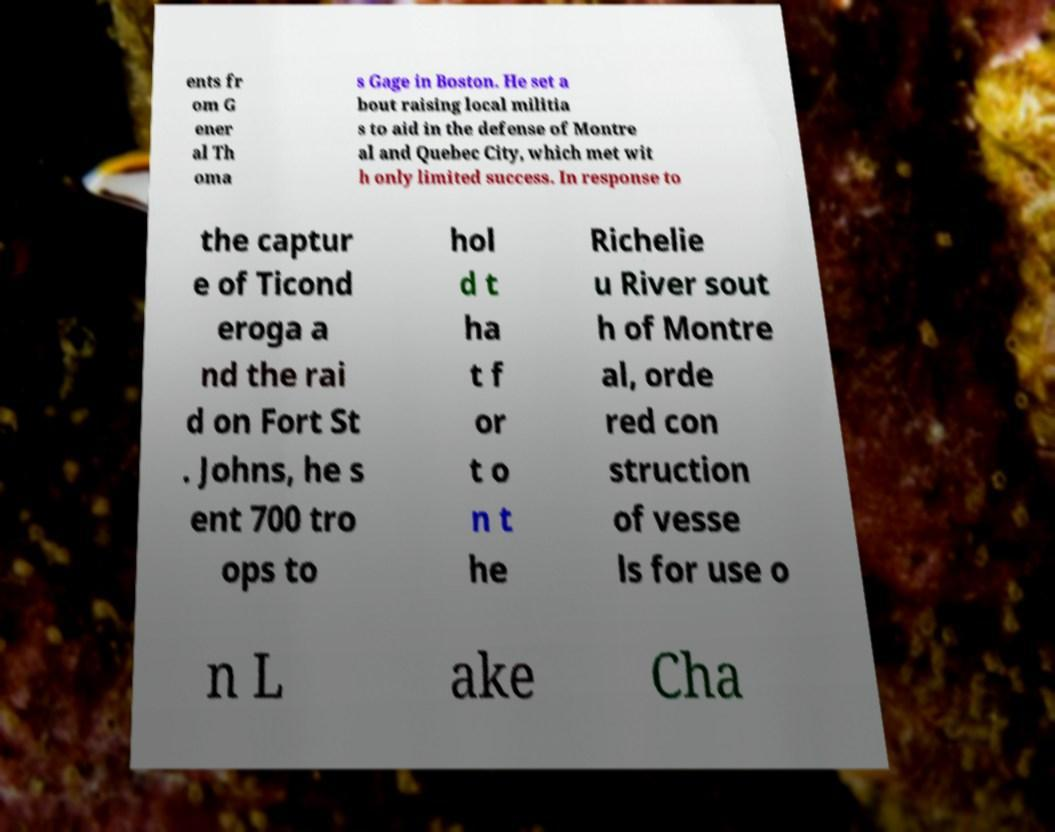Could you assist in decoding the text presented in this image and type it out clearly? ents fr om G ener al Th oma s Gage in Boston. He set a bout raising local militia s to aid in the defense of Montre al and Quebec City, which met wit h only limited success. In response to the captur e of Ticond eroga a nd the rai d on Fort St . Johns, he s ent 700 tro ops to hol d t ha t f or t o n t he Richelie u River sout h of Montre al, orde red con struction of vesse ls for use o n L ake Cha 